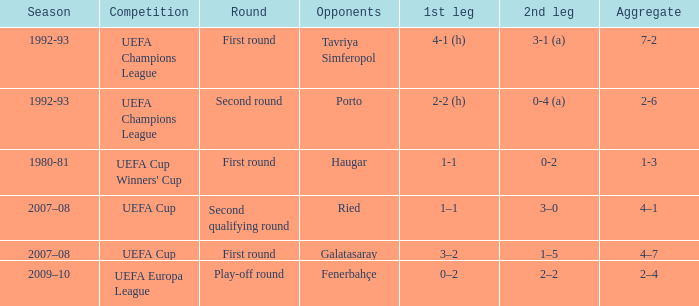What is the total number of round where opponents is haugar 1.0. 